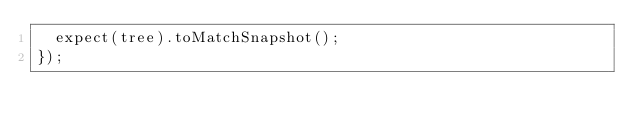<code> <loc_0><loc_0><loc_500><loc_500><_JavaScript_>  expect(tree).toMatchSnapshot();
});
</code> 